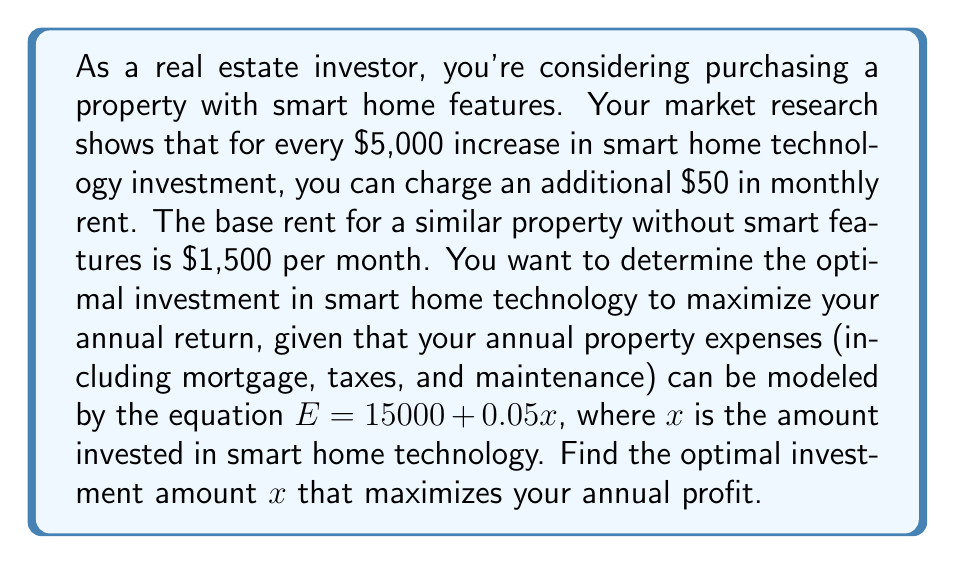Show me your answer to this math problem. Let's approach this step-by-step:

1) First, let's define our variables:
   $x$ = investment in smart home technology (in dollars)
   $R$ = monthly rent
   $E$ = annual expenses

2) We can express the monthly rent as a function of $x$:
   $R = 1500 + 50(\frac{x}{5000}) = 1500 + 0.01x$

3) Annual revenue is 12 times the monthly rent:
   Annual Revenue = $12(1500 + 0.01x) = 18000 + 0.12x$

4) Annual expenses are given by:
   $E = 15000 + 0.05x$

5) Annual profit (P) is revenue minus expenses:
   $P = (18000 + 0.12x) - (15000 + 0.05x)$
   $P = 3000 + 0.07x$

6) To find the maximum profit, we need to consider the constraints. The investment should be non-negative and has a practical upper limit. Let's assume the upper limit is $100,000.

7) Since the profit function is linear and increasing ($0.07x$ is positive), the maximum profit within our constraints will occur at the upper limit of $x$.

8) Therefore, the optimal investment is $x = 100000$.

9) We can verify the profit at this point:
   $P = 3000 + 0.07(100000) = 10000$

This means an annual profit of $10,000 with a $100,000 investment in smart home technology.
Answer: The optimal investment in smart home technology is $100,000, which yields an annual profit of $10,000. 